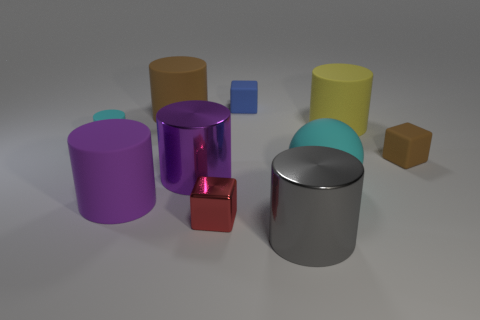Subtract 2 cylinders. How many cylinders are left? 4 Subtract all gray cylinders. How many cylinders are left? 5 Subtract all purple metal cylinders. How many cylinders are left? 5 Subtract all gray cylinders. Subtract all green cubes. How many cylinders are left? 5 Subtract all cubes. How many objects are left? 7 Subtract all big gray shiny cylinders. Subtract all big cylinders. How many objects are left? 4 Add 7 big brown objects. How many big brown objects are left? 8 Add 2 gray metallic cylinders. How many gray metallic cylinders exist? 3 Subtract 1 cyan cylinders. How many objects are left? 9 